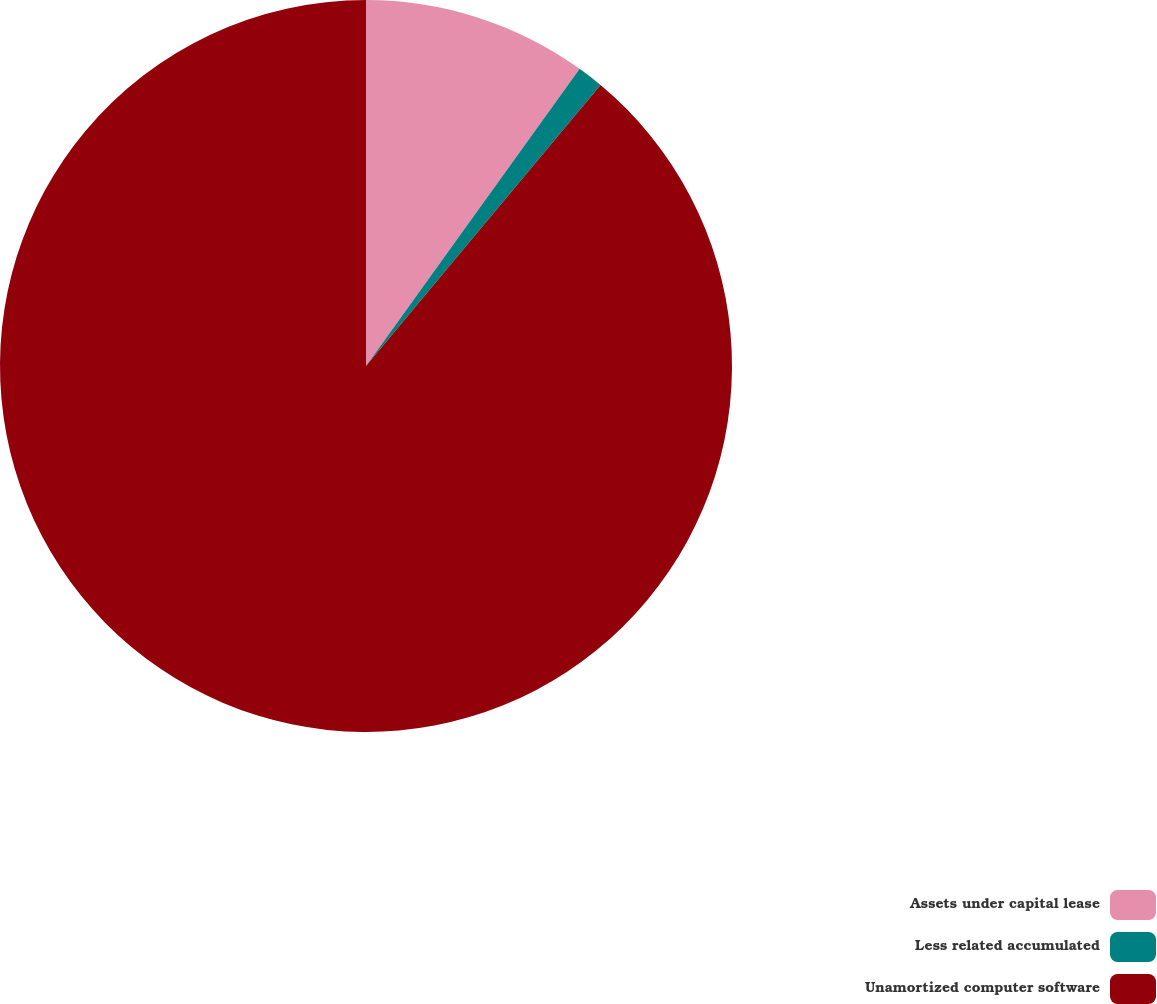Convert chart to OTSL. <chart><loc_0><loc_0><loc_500><loc_500><pie_chart><fcel>Assets under capital lease<fcel>Less related accumulated<fcel>Unamortized computer software<nl><fcel>9.92%<fcel>1.15%<fcel>88.93%<nl></chart> 